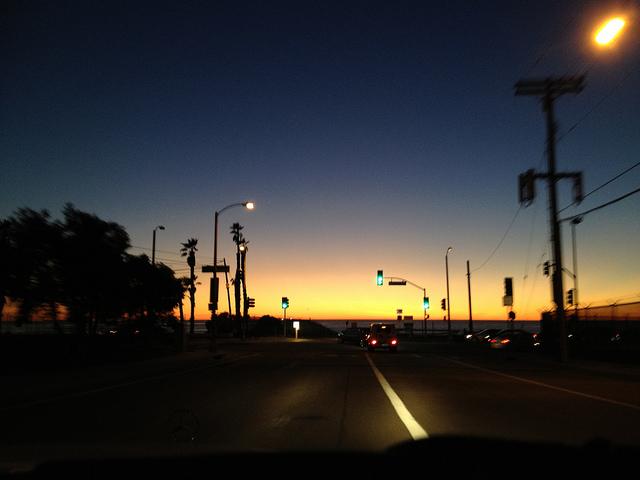Is it day time?
Write a very short answer. No. Where are the traffic lights?
Write a very short answer. In front of car. Is it daytime in the photo?
Short answer required. No. What color are the traffic lights?
Keep it brief. Green. Is there an airplane?
Keep it brief. No. 